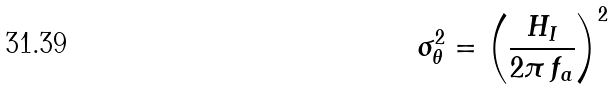Convert formula to latex. <formula><loc_0><loc_0><loc_500><loc_500>\sigma ^ { 2 } _ { \theta } = \left ( \frac { H _ { I } } { 2 \pi \, f _ { a } } \right ) ^ { 2 }</formula> 